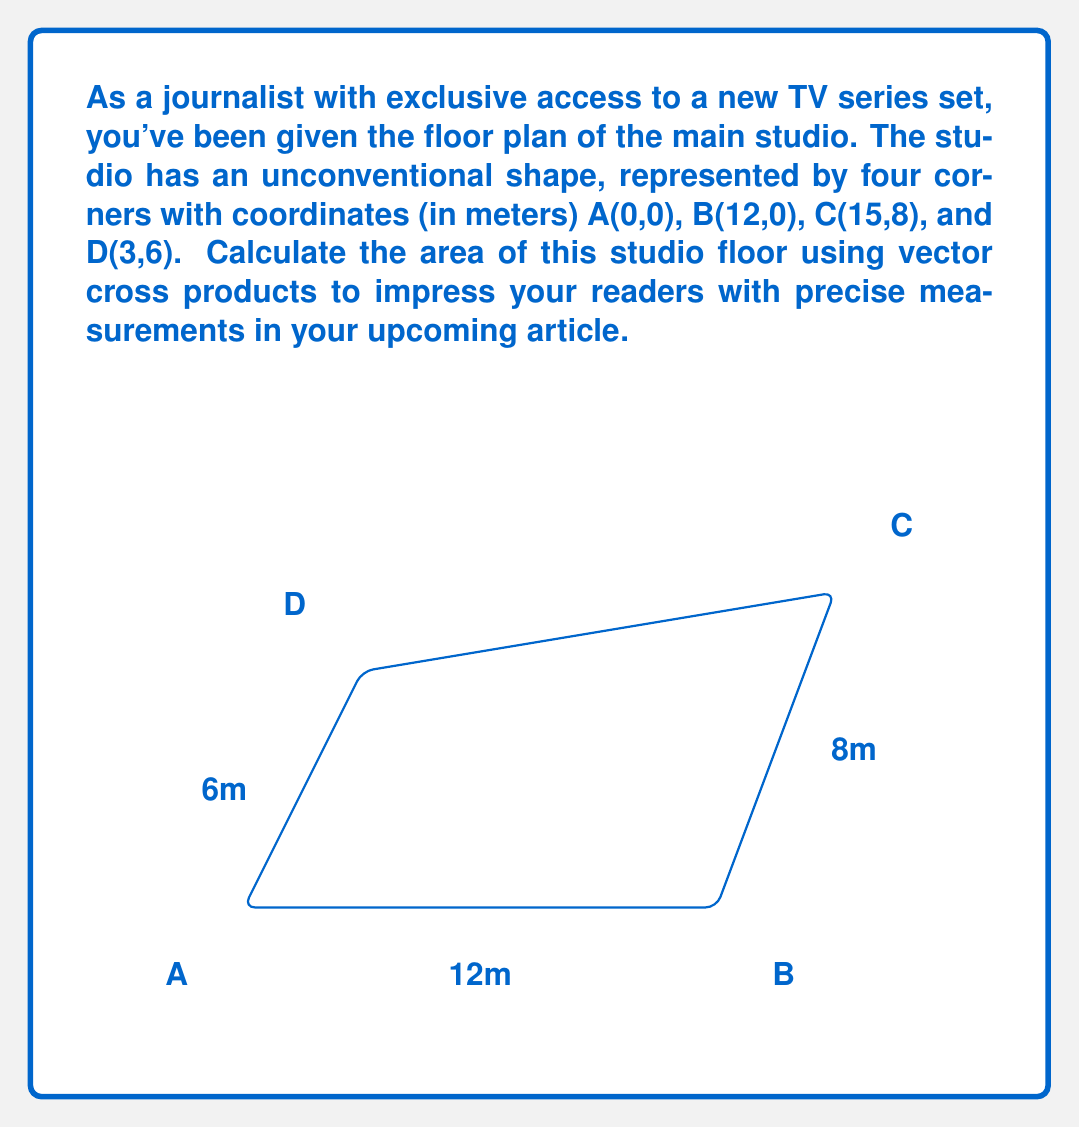Can you solve this math problem? To calculate the area using vector cross products, we'll follow these steps:

1) First, we need to create two vectors. Let's choose $\vec{AB}$ and $\vec{AD}$.

   $\vec{AB} = B - A = (12,0) - (0,0) = (12,0)$
   $\vec{AD} = D - A = (3,6) - (0,0) = (3,6)$

2) The magnitude of the cross product of these vectors will give us the area of the parallelogram ABDA.

   Area$_{ABDA} = |\vec{AB} \times \vec{AD}|$

3) The cross product in 2D can be calculated as:
   
   $\vec{AB} \times \vec{AD} = (12 \cdot 6) - (0 \cdot 3) = 72$

4) This gives us the area of parallelogram ABDA. However, we need the area of quadrilateral ABCD.

5) We can find this by subtracting the area of triangle BCD from the parallelogram ABDA.

6) To find the area of triangle BCD, we use vectors $\vec{BC}$ and $\vec{BD}$:

   $\vec{BC} = C - B = (15,8) - (12,0) = (3,8)$
   $\vec{BD} = D - B = (3,6) - (12,0) = (-9,6)$

7) The area of triangle BCD is half the magnitude of their cross product:

   Area$_{BCD} = \frac{1}{2}|\vec{BC} \times \vec{BD}|$
                $= \frac{1}{2}|(3 \cdot 6) - (8 \cdot -9)|$
                $= \frac{1}{2}|18 + 72| = 45$

8) Therefore, the total area of the studio is:

   Area$_{ABCD} = $ Area$_{ABDA} -$ Area$_{BCD} = 72 - 45 = 27$

Thus, the area of the studio floor is 27 square meters.
Answer: $$27 \text{ m}^2$$ 